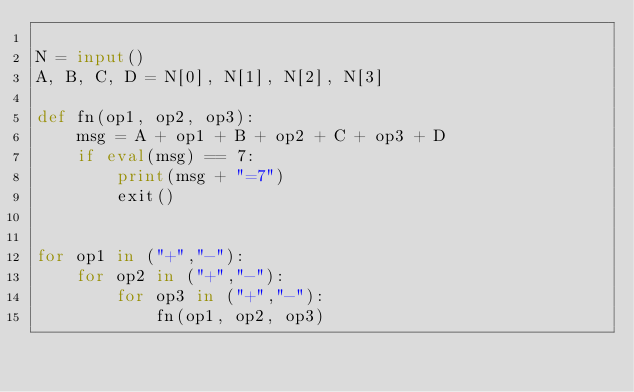Convert code to text. <code><loc_0><loc_0><loc_500><loc_500><_Python_>
N = input()
A, B, C, D = N[0], N[1], N[2], N[3]

def fn(op1, op2, op3):
    msg = A + op1 + B + op2 + C + op3 + D
    if eval(msg) == 7:
        print(msg + "=7")
        exit()


for op1 in ("+","-"):
    for op2 in ("+","-"):
        for op3 in ("+","-"):
            fn(op1, op2, op3)
</code> 